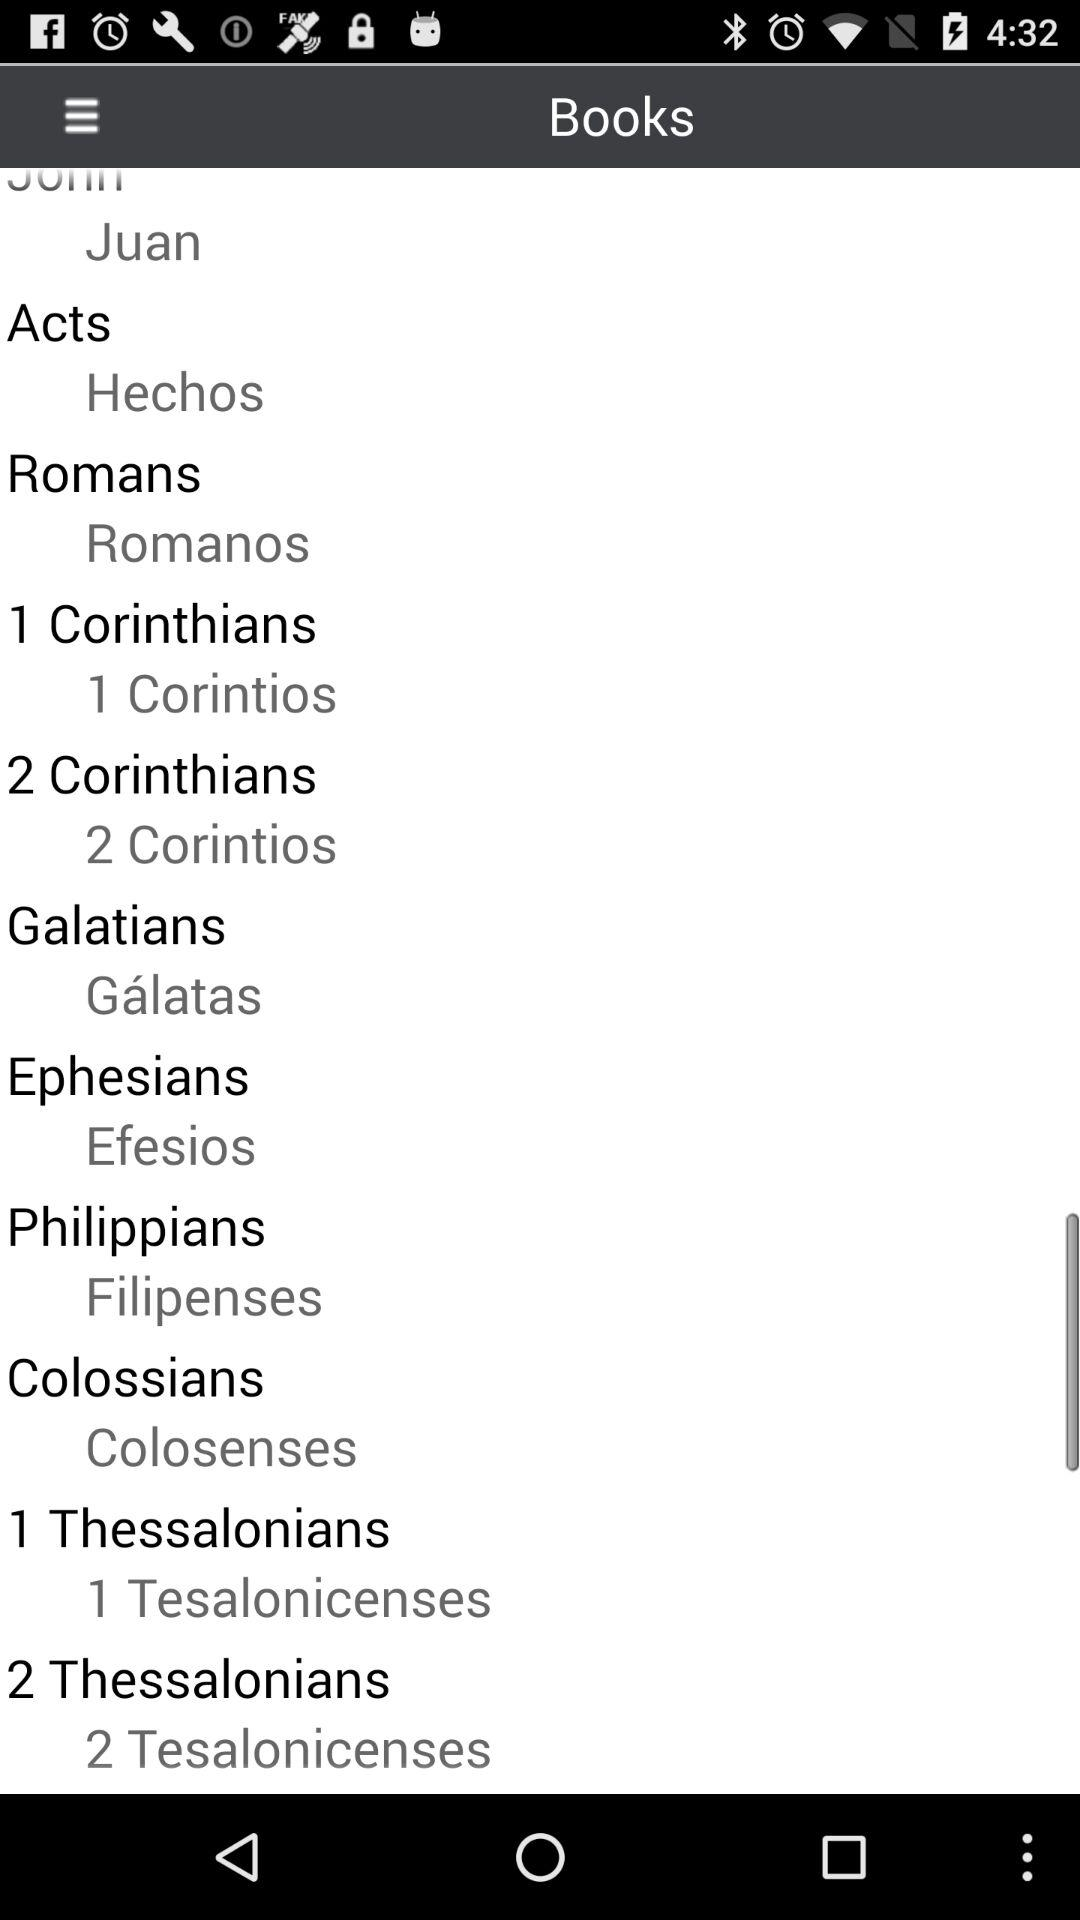What is the name of the "Acts" book in Spanish? The name of the "Acts" book in Spanish is "Hechos". 